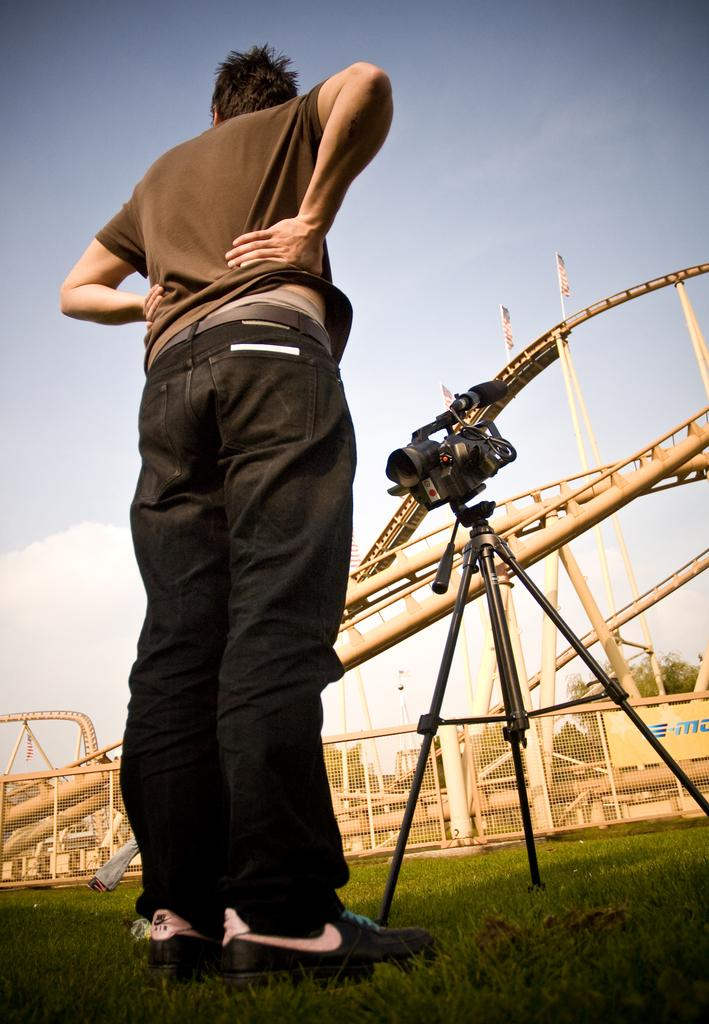What is the person in the image doing? The person is standing on the grass in the image. What equipment is visible in the image? There is a camera on a tripod stand in the image. What type of signage is present in the image? There is a poster in the image. What type of barrier is visible in the image? There is a fence in the image. What type of vertical structures are present in the image? There are poles in the image. What type of decorative or symbolic objects are present in the image? There are flags in the image. What type of natural vegetation is visible in the image? There are trees in the image. What else can be seen in the image? There are some objects in the image. What is visible in the background of the image? The sky is visible in the background of the image. What type of writing instrument is the person using in the image? There is no writing instrument visible in the image. 